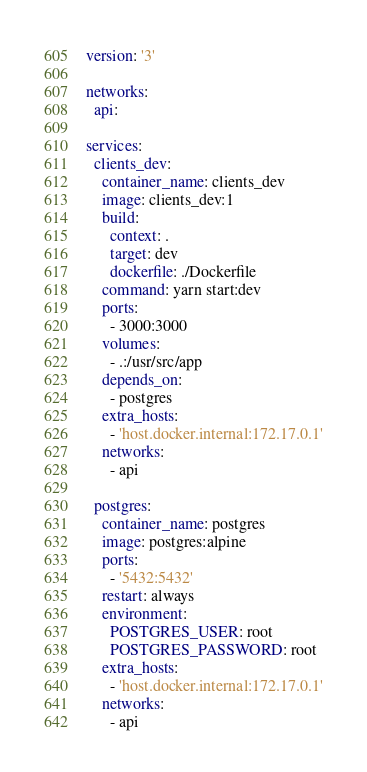Convert code to text. <code><loc_0><loc_0><loc_500><loc_500><_YAML_>version: '3'

networks:
  api:

services:
  clients_dev:
    container_name: clients_dev
    image: clients_dev:1
    build:
      context: .
      target: dev
      dockerfile: ./Dockerfile
    command: yarn start:dev
    ports:
      - 3000:3000
    volumes:
      - .:/usr/src/app
    depends_on:
      - postgres
    extra_hosts:
      - 'host.docker.internal:172.17.0.1'
    networks:
      - api

  postgres:
    container_name: postgres
    image: postgres:alpine
    ports:
      - '5432:5432'
    restart: always
    environment:
      POSTGRES_USER: root
      POSTGRES_PASSWORD: root
    extra_hosts:
      - 'host.docker.internal:172.17.0.1'
    networks:
      - api
</code> 